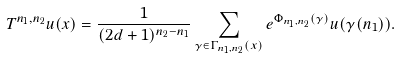Convert formula to latex. <formula><loc_0><loc_0><loc_500><loc_500>T ^ { n _ { 1 } , n _ { 2 } } u ( x ) = \frac { 1 } { ( 2 d + 1 ) ^ { n _ { 2 } - n _ { 1 } } } \sum _ { \gamma \in \Gamma _ { n _ { 1 } , n _ { 2 } } ( x ) } e ^ { \Phi _ { n _ { 1 } , n _ { 2 } } ( \gamma ) } u ( \gamma ( n _ { 1 } ) ) .</formula> 